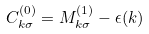Convert formula to latex. <formula><loc_0><loc_0><loc_500><loc_500>C _ { k \sigma } ^ { ( 0 ) } = M _ { k \sigma } ^ { ( 1 ) } - \epsilon ( k )</formula> 